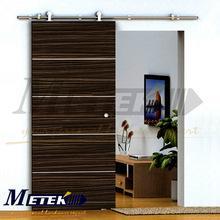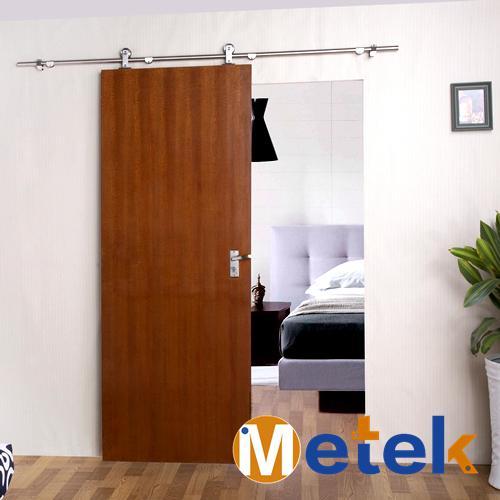The first image is the image on the left, the second image is the image on the right. For the images shown, is this caption "In one image, the door has a horizontal strip wood grain pattern." true? Answer yes or no. Yes. 